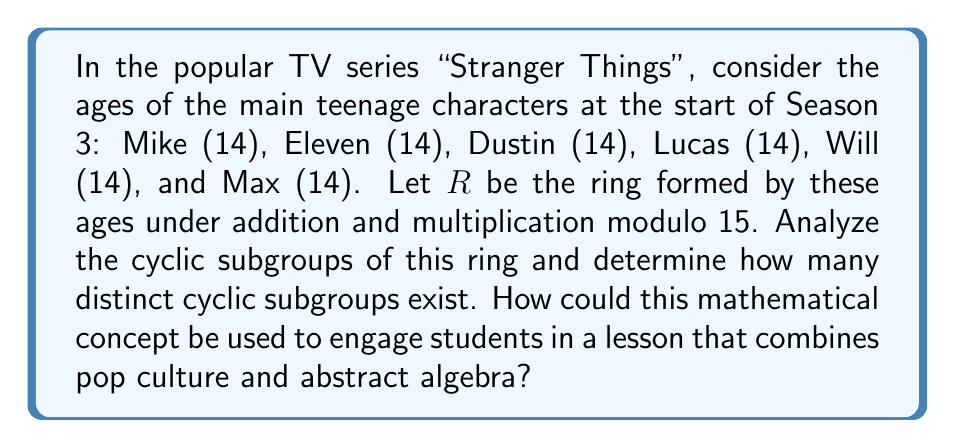Help me with this question. Let's approach this step-by-step:

1) First, we need to understand the ring $R$. It consists of the set $\{14, 0\}$ under addition and multiplication modulo 15.

2) To find cyclic subgroups, we need to consider the additive and multiplicative structures separately.

3) Additive structure:
   $14 + 14 \equiv 13 \pmod{15}$
   $14 + 14 + 14 \equiv 12 \pmod{15}$
   $14 + 14 + 14 + 14 \equiv 11 \pmod{15}$
   ...
   After 15 additions, we get back to 14.

   So, the additive cyclic subgroup generated by 14 is $\{14, 13, 12, 11, 10, 9, 8, 7, 6, 5, 4, 3, 2, 1, 0\}$, which is the entire ring.

4) Multiplicative structure:
   $14 \cdot 14 \equiv 1 \pmod{15}$
   $14 \cdot 14 \cdot 14 \equiv 14 \pmod{15}$

   So, the multiplicative cyclic subgroup generated by 14 is $\{14, 1\}$.

5) The element 0 generates the trivial subgroup $\{0\}$ under both addition and multiplication.

6) Therefore, there are 3 distinct cyclic subgroups:
   - $\{0\}$ (trivial subgroup)
   - $\{14, 1\}$ (multiplicative cyclic subgroup generated by 14)
   - $\{14, 13, 12, 11, 10, 9, 8, 7, 6, 5, 4, 3, 2, 1, 0\}$ (additive cyclic subgroup, which is the entire ring)

To incorporate this into a lesson combining pop culture and abstract algebra:

1) Start by discussing the TV series and the characters' ages, making the math relatable.
2) Introduce the concept of modular arithmetic using the characters' ages.
3) Use the cyclic subgroups to discuss group theory concepts like generators and order.
4) Draw parallels between the cyclic nature of the subgroups and the cyclical nature of the show's seasons or plot elements.
5) Encourage students to find other examples in pop culture where mathematical structures might be hidden.

This approach makes abstract algebraic concepts more tangible by connecting them to a popular TV series, potentially increasing student engagement and understanding.
Answer: There are 3 distinct cyclic subgroups in the ring $R$: the trivial subgroup $\{0\}$, the multiplicative cyclic subgroup $\{14, 1\}$, and the additive cyclic subgroup $\{14, 13, 12, 11, 10, 9, 8, 7, 6, 5, 4, 3, 2, 1, 0\}$ which is the entire ring. 